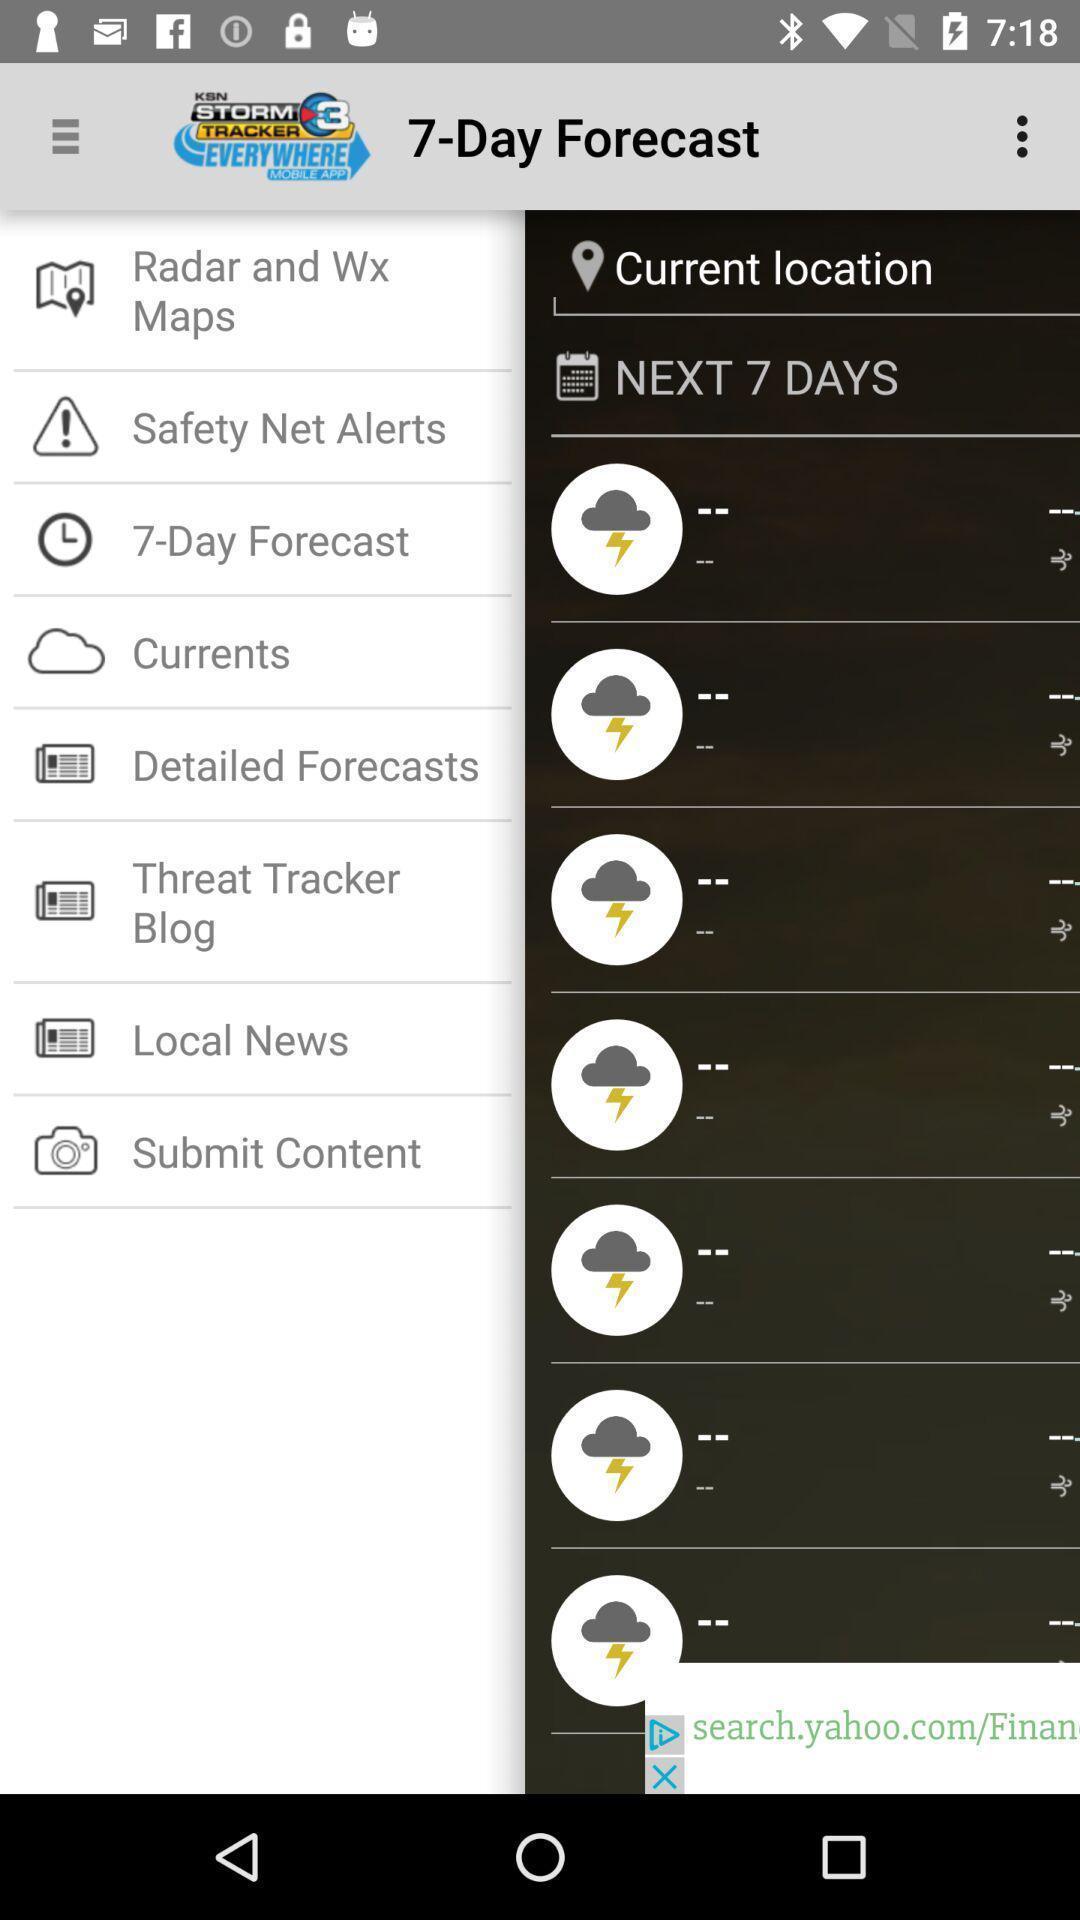Summarize the information in this screenshot. Screen displaying multiple options in a weather application. 